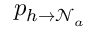<formula> <loc_0><loc_0><loc_500><loc_500>p _ { h \to \mathcal { N } _ { a } }</formula> 